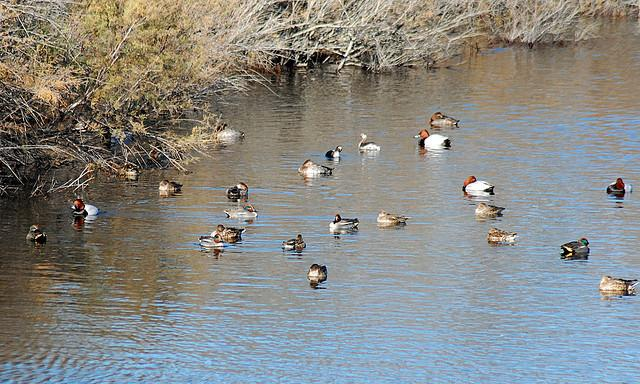What are the males called? Please explain your reasoning. drakes. The male ducks are drakes. 